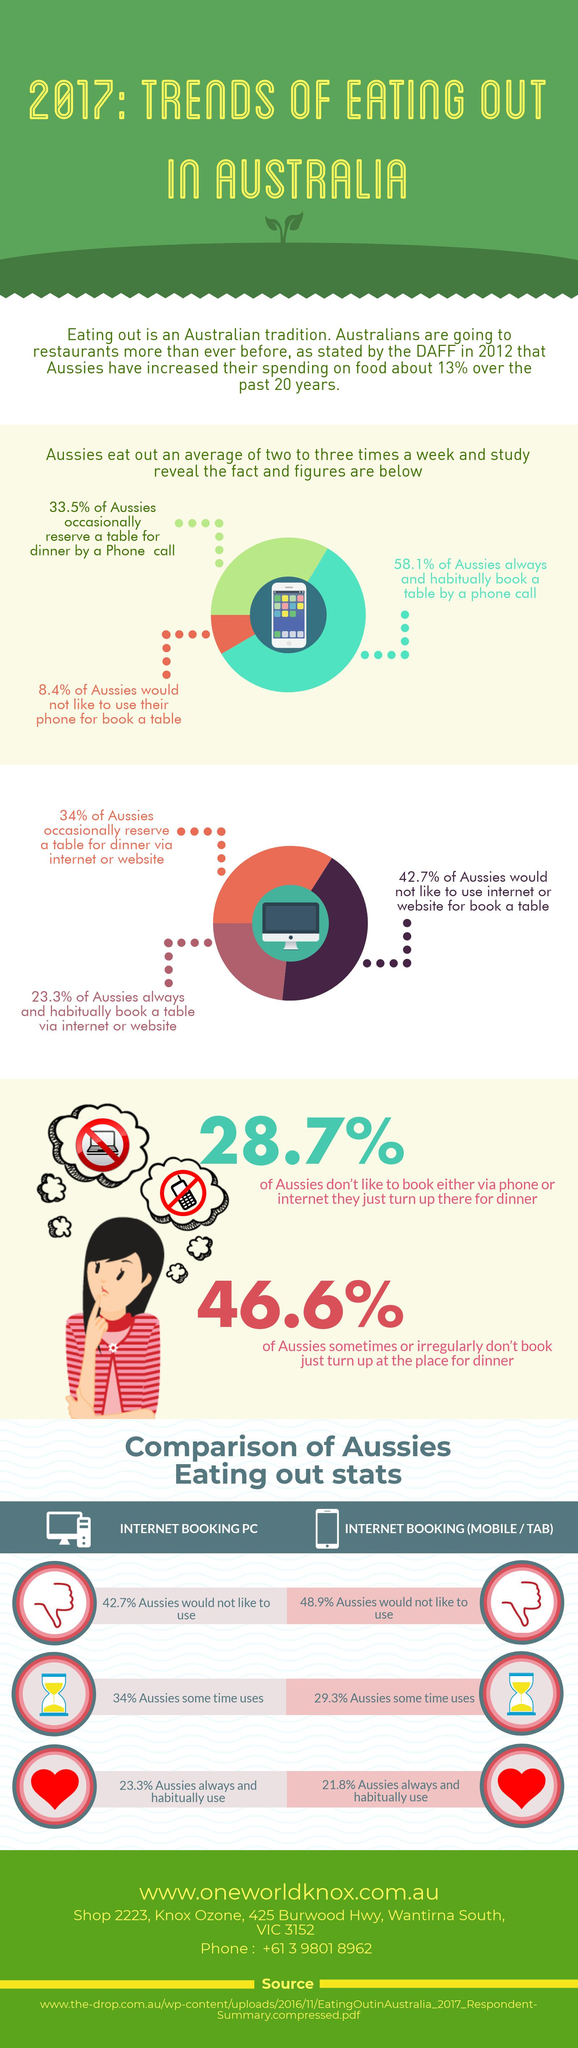Specify some key components in this picture. According to the survey, 48.9% of Australians do not want to use Internet booking through their mobile or tablet devices. A significant portion, around 34%, of Australians occasionally use online booking on their personal computer. According to the data, 21.8% of Australians always and habitually use internet booking (mobile or tab). In Australia, it was reported that 57.3% of people reserve a table for dinner by either occasionally or always and habitually using the internet or website. According to the survey, 91.6% of Australians either occasionally or always and habitually book a table by phone call. 